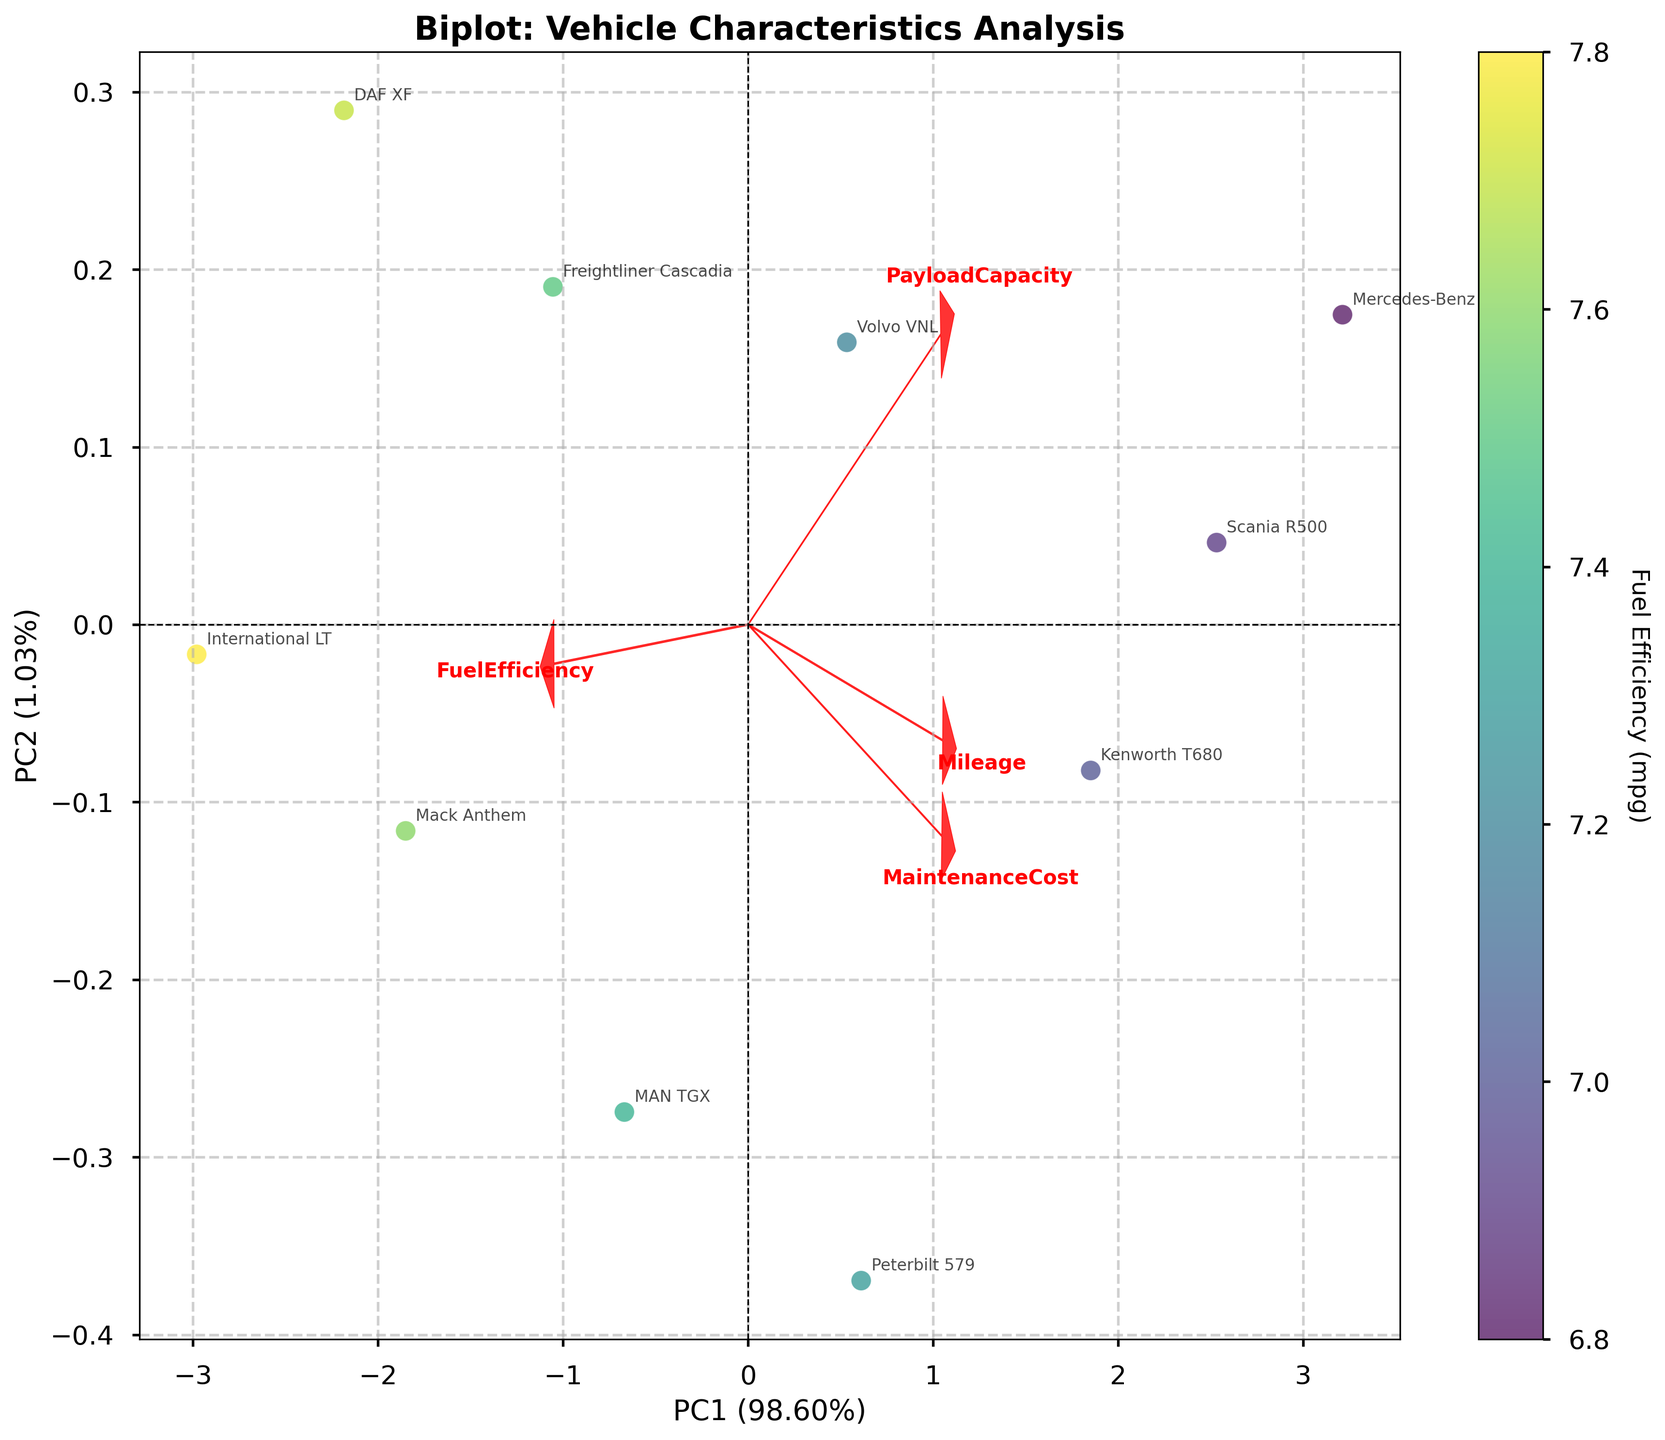What is the title of the biplot? The title of the biplot is displayed at the top of the figure in a bold, larger font. It states the main theme or focus of the plot.
Answer: Biplot: Vehicle Characteristics Analysis How many truck models are plotted in the biplot? By counting the number of unique annotations or labels placed around the scatter points in the biplot, you can determine the number of truck models. Each label corresponds to a truck model.
Answer: 10 Which truck model has the highest fuel efficiency? The color of the scatter points represents the fuel efficiency. The truck model with the brightest color, closest to the top range of the colorbar, indicates the highest fuel efficiency.
Answer: International LT Which truck model is associated with the highest Maintenance Cost? Look at the direction and magnitude of the 'MaintenanceCost' loading vector. The further along this vector a truck model is, the higher its maintenance cost. The truck located furthest in this direction represents the highest maintenance cost.
Answer: Mercedes-Benz Actros What percentage of the variance does the first principal component (PC1) explain? The explanation is provided in the axis label for PC1. It is given as a percentage, denoting the amount of variance captured by the first principal component.
Answer: 83% Which feature seems to be more associated with PC2 than PC1? The loading vectors for each feature indicate their association with the principal components. The feature with the larger projection on PC2, relative to PC1, is more associated with PC2.
Answer: Mileage Between Volvo VNL and Kenworth T680, which model has a higher maintenance cost? Locate the annotations for both Volvo VNL and Kenworth T680 on the biplot. The model positioned further along the 'MaintenanceCost' vector indicates a higher maintenance cost.
Answer: Kenworth T680 Which principal component is more associated with fuel efficiency? The loading vector for 'FuelEfficiency' indicates its association with the principal components. The greater the projection on one of the principal component axes, the more it is associated with it.
Answer: PC2 How does the mileage of Mercedes-Benz Actros compare to that of Mack Anthem? Check the positions of the truck models along the 'Mileage' vector. The model positioned further in this direction has a higher mileage.
Answer: Higher Which two features have the most similar direction and magnitude of loading vectors? Compare the direction and length of the loading vectors for all features. The two vectors that are closest in direction and length are the most similar.
Answer: MaintenanceCost and PayloadCapacity 